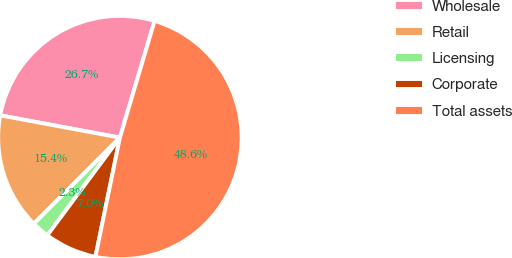Convert chart to OTSL. <chart><loc_0><loc_0><loc_500><loc_500><pie_chart><fcel>Wholesale<fcel>Retail<fcel>Licensing<fcel>Corporate<fcel>Total assets<nl><fcel>26.67%<fcel>15.43%<fcel>2.32%<fcel>6.95%<fcel>48.62%<nl></chart> 